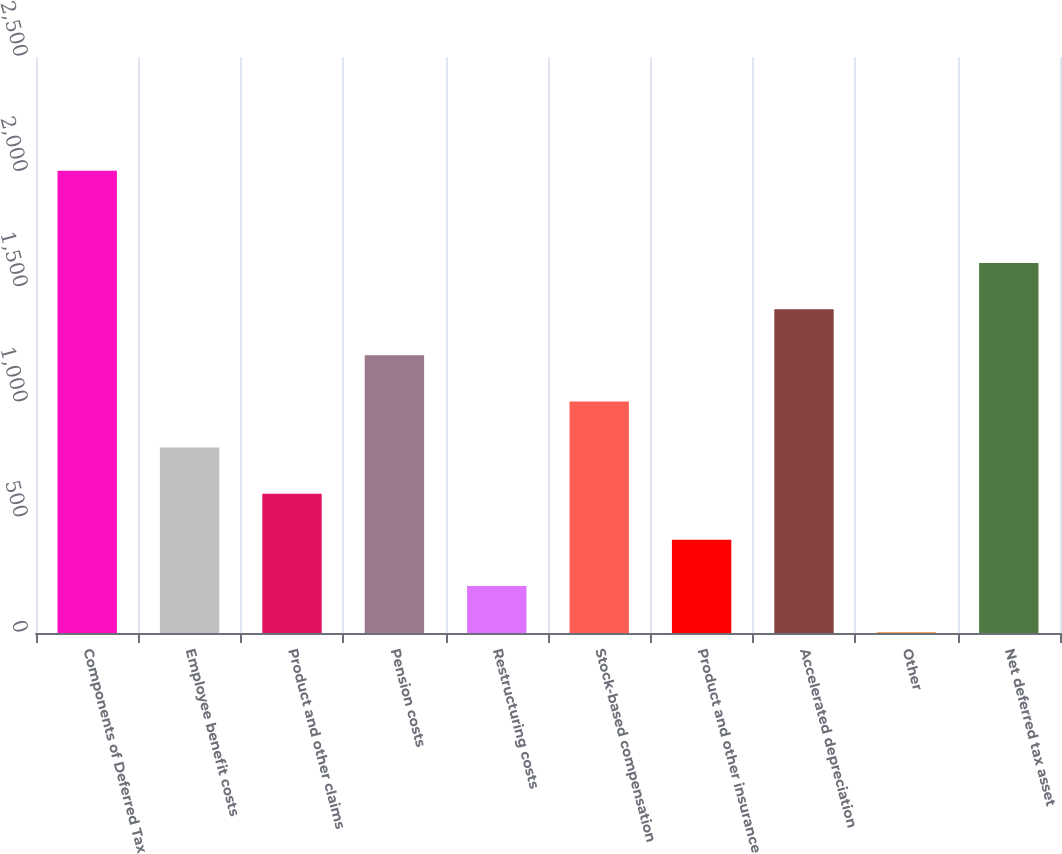<chart> <loc_0><loc_0><loc_500><loc_500><bar_chart><fcel>Components of Deferred Tax<fcel>Employee benefit costs<fcel>Product and other claims<fcel>Pension costs<fcel>Restructuring costs<fcel>Stock-based compensation<fcel>Product and other insurance<fcel>Accelerated depreciation<fcel>Other<fcel>Net deferred tax asset<nl><fcel>2006<fcel>804.8<fcel>604.6<fcel>1205.2<fcel>204.2<fcel>1005<fcel>404.4<fcel>1405.4<fcel>4<fcel>1605.6<nl></chart> 